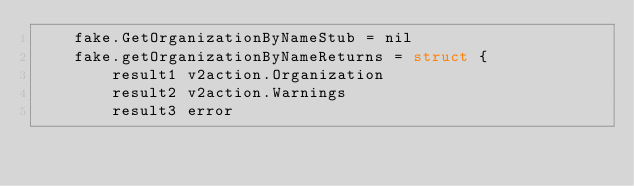<code> <loc_0><loc_0><loc_500><loc_500><_Go_>	fake.GetOrganizationByNameStub = nil
	fake.getOrganizationByNameReturns = struct {
		result1 v2action.Organization
		result2 v2action.Warnings
		result3 error</code> 